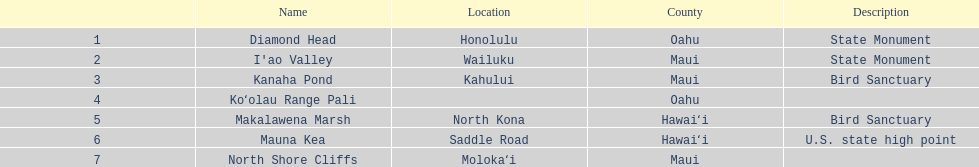What are all of the landmark names in hawaii? Diamond Head, I'ao Valley, Kanaha Pond, Koʻolau Range Pali, Makalawena Marsh, Mauna Kea, North Shore Cliffs. Can you give me this table in json format? {'header': ['', 'Name', 'Location', 'County', 'Description'], 'rows': [['1', 'Diamond Head', 'Honolulu', 'Oahu', 'State Monument'], ['2', "I'ao Valley", 'Wailuku', 'Maui', 'State Monument'], ['3', 'Kanaha Pond', 'Kahului', 'Maui', 'Bird Sanctuary'], ['4', 'Koʻolau Range Pali', '', 'Oahu', ''], ['5', 'Makalawena Marsh', 'North Kona', 'Hawaiʻi', 'Bird Sanctuary'], ['6', 'Mauna Kea', 'Saddle Road', 'Hawaiʻi', 'U.S. state high point'], ['7', 'North Shore Cliffs', 'Molokaʻi', 'Maui', '']]} What are their descriptions? State Monument, State Monument, Bird Sanctuary, , Bird Sanctuary, U.S. state high point, . And which is described as a u.s. state high point? Mauna Kea. 